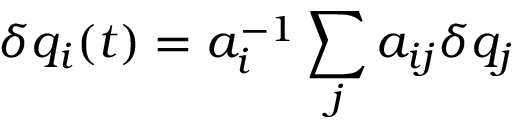Convert formula to latex. <formula><loc_0><loc_0><loc_500><loc_500>\delta q _ { i } ( t ) = a _ { i } ^ { - 1 } \sum _ { j } a _ { i j } \delta q _ { j }</formula> 